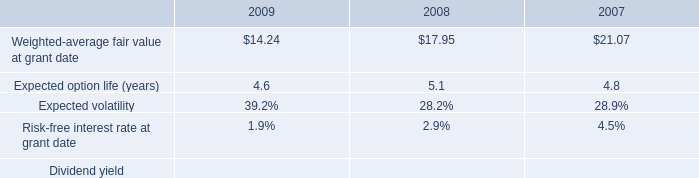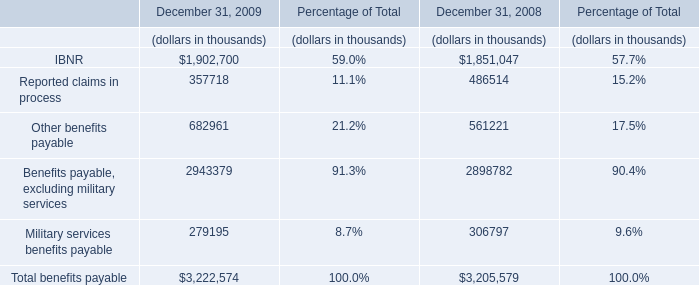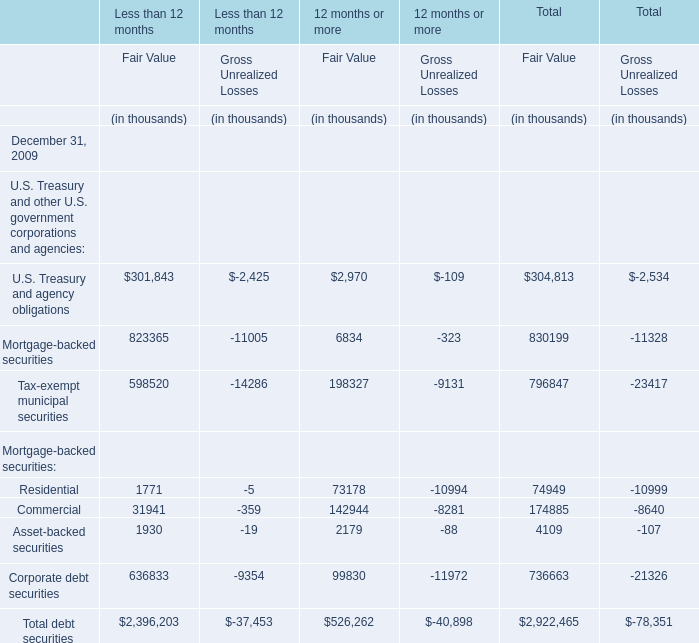What is the average value of U.S. Treasury and agency obligations for Fair Value in Less than 12 months and IBNR in 2009? 
Computations: ((1902700 + 301843) / 2)
Answer: 1102271.5. 